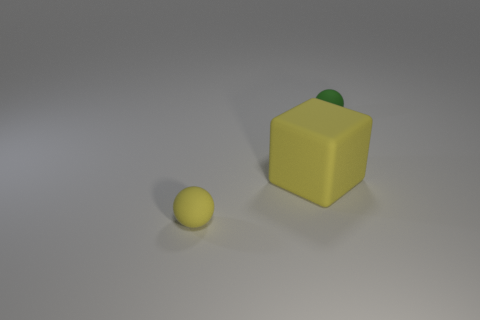Subtract all yellow spheres. How many spheres are left? 1 Add 3 small purple matte things. How many objects exist? 6 Subtract all balls. How many objects are left? 1 Subtract 1 blocks. How many blocks are left? 0 Subtract all brown balls. How many blue cubes are left? 0 Add 1 small rubber objects. How many small rubber objects are left? 3 Add 2 large gray objects. How many large gray objects exist? 2 Subtract 1 yellow spheres. How many objects are left? 2 Subtract all gray spheres. Subtract all cyan cylinders. How many spheres are left? 2 Subtract all large rubber cubes. Subtract all brown matte objects. How many objects are left? 2 